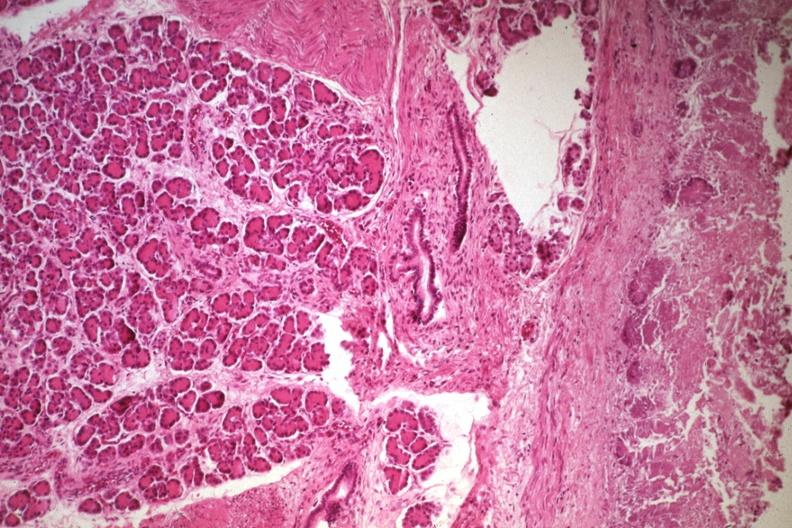where is this from?
Answer the question using a single word or phrase. Gastrointestinal system 